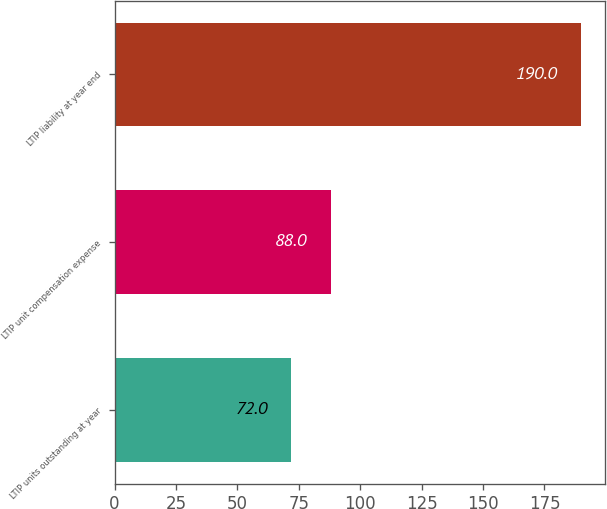Convert chart to OTSL. <chart><loc_0><loc_0><loc_500><loc_500><bar_chart><fcel>LTIP units outstanding at year<fcel>LTIP unit compensation expense<fcel>LTIP liability at year end<nl><fcel>72<fcel>88<fcel>190<nl></chart> 